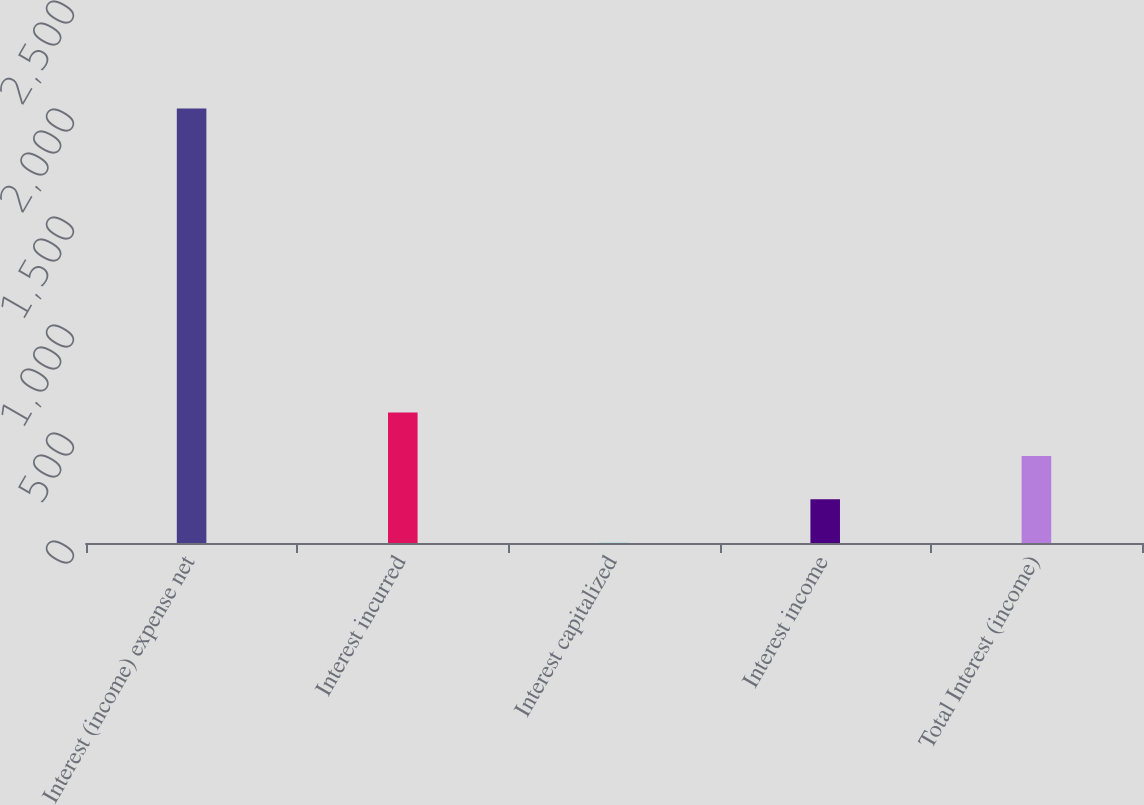Convert chart. <chart><loc_0><loc_0><loc_500><loc_500><bar_chart><fcel>Interest (income) expense net<fcel>Interest incurred<fcel>Interest capitalized<fcel>Interest income<fcel>Total Interest (income)<nl><fcel>2011<fcel>604<fcel>1<fcel>202<fcel>403<nl></chart> 